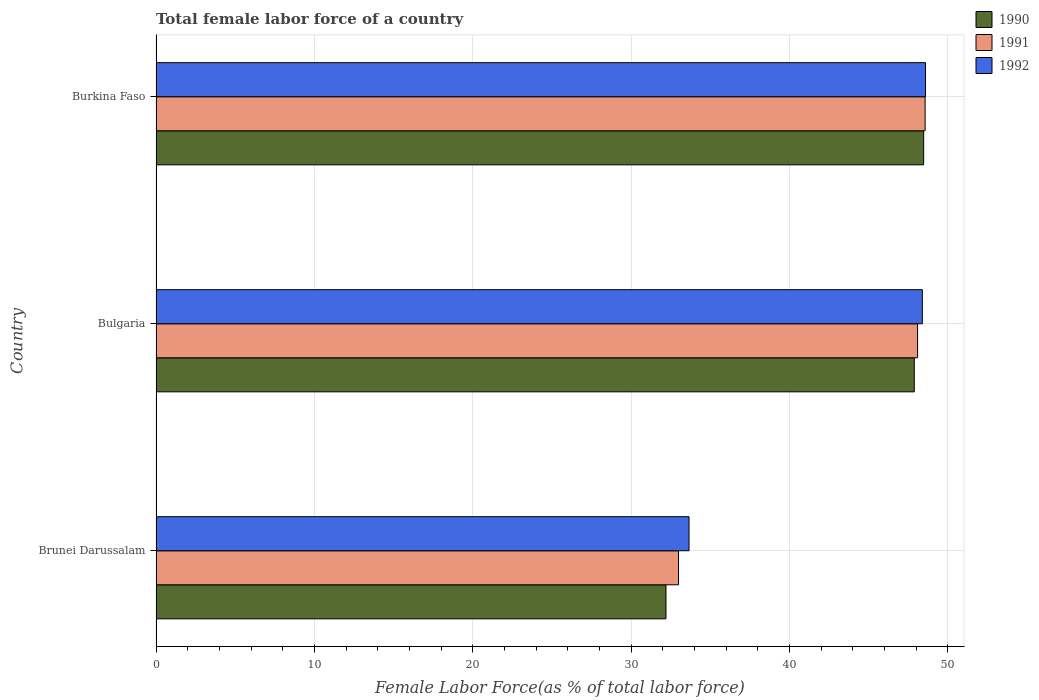How many different coloured bars are there?
Give a very brief answer. 3. How many bars are there on the 2nd tick from the top?
Ensure brevity in your answer.  3. How many bars are there on the 2nd tick from the bottom?
Your response must be concise. 3. What is the label of the 2nd group of bars from the top?
Offer a terse response. Bulgaria. In how many cases, is the number of bars for a given country not equal to the number of legend labels?
Your response must be concise. 0. What is the percentage of female labor force in 1992 in Burkina Faso?
Ensure brevity in your answer.  48.59. Across all countries, what is the maximum percentage of female labor force in 1992?
Your response must be concise. 48.59. Across all countries, what is the minimum percentage of female labor force in 1992?
Offer a terse response. 33.66. In which country was the percentage of female labor force in 1990 maximum?
Provide a short and direct response. Burkina Faso. In which country was the percentage of female labor force in 1990 minimum?
Ensure brevity in your answer.  Brunei Darussalam. What is the total percentage of female labor force in 1992 in the graph?
Offer a very short reply. 130.65. What is the difference between the percentage of female labor force in 1991 in Bulgaria and that in Burkina Faso?
Your answer should be compact. -0.48. What is the difference between the percentage of female labor force in 1992 in Brunei Darussalam and the percentage of female labor force in 1991 in Bulgaria?
Give a very brief answer. -14.43. What is the average percentage of female labor force in 1992 per country?
Offer a very short reply. 43.55. What is the difference between the percentage of female labor force in 1992 and percentage of female labor force in 1991 in Burkina Faso?
Make the answer very short. 0.03. In how many countries, is the percentage of female labor force in 1991 greater than 12 %?
Provide a short and direct response. 3. What is the ratio of the percentage of female labor force in 1990 in Brunei Darussalam to that in Bulgaria?
Make the answer very short. 0.67. Is the percentage of female labor force in 1990 in Bulgaria less than that in Burkina Faso?
Keep it short and to the point. Yes. What is the difference between the highest and the second highest percentage of female labor force in 1990?
Offer a terse response. 0.59. What is the difference between the highest and the lowest percentage of female labor force in 1991?
Your response must be concise. 15.57. In how many countries, is the percentage of female labor force in 1990 greater than the average percentage of female labor force in 1990 taken over all countries?
Offer a terse response. 2. Is the sum of the percentage of female labor force in 1992 in Brunei Darussalam and Bulgaria greater than the maximum percentage of female labor force in 1991 across all countries?
Your answer should be very brief. Yes. What does the 2nd bar from the bottom in Brunei Darussalam represents?
Ensure brevity in your answer.  1991. How many bars are there?
Offer a terse response. 9. Are all the bars in the graph horizontal?
Offer a very short reply. Yes. How many countries are there in the graph?
Make the answer very short. 3. What is the difference between two consecutive major ticks on the X-axis?
Give a very brief answer. 10. Are the values on the major ticks of X-axis written in scientific E-notation?
Make the answer very short. No. Does the graph contain grids?
Ensure brevity in your answer.  Yes. How many legend labels are there?
Make the answer very short. 3. How are the legend labels stacked?
Give a very brief answer. Vertical. What is the title of the graph?
Ensure brevity in your answer.  Total female labor force of a country. What is the label or title of the X-axis?
Provide a succinct answer. Female Labor Force(as % of total labor force). What is the Female Labor Force(as % of total labor force) in 1990 in Brunei Darussalam?
Keep it short and to the point. 32.2. What is the Female Labor Force(as % of total labor force) of 1991 in Brunei Darussalam?
Your response must be concise. 33. What is the Female Labor Force(as % of total labor force) of 1992 in Brunei Darussalam?
Ensure brevity in your answer.  33.66. What is the Female Labor Force(as % of total labor force) in 1990 in Bulgaria?
Your response must be concise. 47.88. What is the Female Labor Force(as % of total labor force) in 1991 in Bulgaria?
Provide a succinct answer. 48.09. What is the Female Labor Force(as % of total labor force) of 1992 in Bulgaria?
Give a very brief answer. 48.39. What is the Female Labor Force(as % of total labor force) of 1990 in Burkina Faso?
Give a very brief answer. 48.48. What is the Female Labor Force(as % of total labor force) of 1991 in Burkina Faso?
Provide a short and direct response. 48.57. What is the Female Labor Force(as % of total labor force) of 1992 in Burkina Faso?
Your answer should be compact. 48.59. Across all countries, what is the maximum Female Labor Force(as % of total labor force) in 1990?
Your answer should be compact. 48.48. Across all countries, what is the maximum Female Labor Force(as % of total labor force) of 1991?
Your answer should be very brief. 48.57. Across all countries, what is the maximum Female Labor Force(as % of total labor force) of 1992?
Your answer should be compact. 48.59. Across all countries, what is the minimum Female Labor Force(as % of total labor force) of 1990?
Provide a short and direct response. 32.2. Across all countries, what is the minimum Female Labor Force(as % of total labor force) of 1991?
Your response must be concise. 33. Across all countries, what is the minimum Female Labor Force(as % of total labor force) of 1992?
Keep it short and to the point. 33.66. What is the total Female Labor Force(as % of total labor force) in 1990 in the graph?
Offer a very short reply. 128.57. What is the total Female Labor Force(as % of total labor force) of 1991 in the graph?
Your response must be concise. 129.66. What is the total Female Labor Force(as % of total labor force) of 1992 in the graph?
Provide a short and direct response. 130.65. What is the difference between the Female Labor Force(as % of total labor force) in 1990 in Brunei Darussalam and that in Bulgaria?
Give a very brief answer. -15.68. What is the difference between the Female Labor Force(as % of total labor force) of 1991 in Brunei Darussalam and that in Bulgaria?
Your response must be concise. -15.1. What is the difference between the Female Labor Force(as % of total labor force) in 1992 in Brunei Darussalam and that in Bulgaria?
Offer a very short reply. -14.73. What is the difference between the Female Labor Force(as % of total labor force) in 1990 in Brunei Darussalam and that in Burkina Faso?
Your response must be concise. -16.27. What is the difference between the Female Labor Force(as % of total labor force) in 1991 in Brunei Darussalam and that in Burkina Faso?
Provide a short and direct response. -15.57. What is the difference between the Female Labor Force(as % of total labor force) in 1992 in Brunei Darussalam and that in Burkina Faso?
Ensure brevity in your answer.  -14.93. What is the difference between the Female Labor Force(as % of total labor force) in 1990 in Bulgaria and that in Burkina Faso?
Make the answer very short. -0.59. What is the difference between the Female Labor Force(as % of total labor force) in 1991 in Bulgaria and that in Burkina Faso?
Your response must be concise. -0.48. What is the difference between the Female Labor Force(as % of total labor force) of 1992 in Bulgaria and that in Burkina Faso?
Give a very brief answer. -0.2. What is the difference between the Female Labor Force(as % of total labor force) of 1990 in Brunei Darussalam and the Female Labor Force(as % of total labor force) of 1991 in Bulgaria?
Ensure brevity in your answer.  -15.89. What is the difference between the Female Labor Force(as % of total labor force) in 1990 in Brunei Darussalam and the Female Labor Force(as % of total labor force) in 1992 in Bulgaria?
Keep it short and to the point. -16.19. What is the difference between the Female Labor Force(as % of total labor force) of 1991 in Brunei Darussalam and the Female Labor Force(as % of total labor force) of 1992 in Bulgaria?
Give a very brief answer. -15.4. What is the difference between the Female Labor Force(as % of total labor force) in 1990 in Brunei Darussalam and the Female Labor Force(as % of total labor force) in 1991 in Burkina Faso?
Provide a short and direct response. -16.36. What is the difference between the Female Labor Force(as % of total labor force) of 1990 in Brunei Darussalam and the Female Labor Force(as % of total labor force) of 1992 in Burkina Faso?
Keep it short and to the point. -16.39. What is the difference between the Female Labor Force(as % of total labor force) of 1991 in Brunei Darussalam and the Female Labor Force(as % of total labor force) of 1992 in Burkina Faso?
Your response must be concise. -15.6. What is the difference between the Female Labor Force(as % of total labor force) of 1990 in Bulgaria and the Female Labor Force(as % of total labor force) of 1991 in Burkina Faso?
Your answer should be compact. -0.68. What is the difference between the Female Labor Force(as % of total labor force) of 1990 in Bulgaria and the Female Labor Force(as % of total labor force) of 1992 in Burkina Faso?
Your response must be concise. -0.71. What is the difference between the Female Labor Force(as % of total labor force) in 1991 in Bulgaria and the Female Labor Force(as % of total labor force) in 1992 in Burkina Faso?
Your response must be concise. -0.5. What is the average Female Labor Force(as % of total labor force) in 1990 per country?
Make the answer very short. 42.86. What is the average Female Labor Force(as % of total labor force) of 1991 per country?
Provide a succinct answer. 43.22. What is the average Female Labor Force(as % of total labor force) of 1992 per country?
Make the answer very short. 43.55. What is the difference between the Female Labor Force(as % of total labor force) of 1990 and Female Labor Force(as % of total labor force) of 1991 in Brunei Darussalam?
Offer a terse response. -0.79. What is the difference between the Female Labor Force(as % of total labor force) in 1990 and Female Labor Force(as % of total labor force) in 1992 in Brunei Darussalam?
Make the answer very short. -1.46. What is the difference between the Female Labor Force(as % of total labor force) in 1991 and Female Labor Force(as % of total labor force) in 1992 in Brunei Darussalam?
Provide a succinct answer. -0.66. What is the difference between the Female Labor Force(as % of total labor force) of 1990 and Female Labor Force(as % of total labor force) of 1991 in Bulgaria?
Provide a succinct answer. -0.21. What is the difference between the Female Labor Force(as % of total labor force) of 1990 and Female Labor Force(as % of total labor force) of 1992 in Bulgaria?
Give a very brief answer. -0.51. What is the difference between the Female Labor Force(as % of total labor force) of 1991 and Female Labor Force(as % of total labor force) of 1992 in Bulgaria?
Your answer should be very brief. -0.3. What is the difference between the Female Labor Force(as % of total labor force) in 1990 and Female Labor Force(as % of total labor force) in 1991 in Burkina Faso?
Offer a terse response. -0.09. What is the difference between the Female Labor Force(as % of total labor force) of 1990 and Female Labor Force(as % of total labor force) of 1992 in Burkina Faso?
Provide a succinct answer. -0.12. What is the difference between the Female Labor Force(as % of total labor force) in 1991 and Female Labor Force(as % of total labor force) in 1992 in Burkina Faso?
Your response must be concise. -0.03. What is the ratio of the Female Labor Force(as % of total labor force) in 1990 in Brunei Darussalam to that in Bulgaria?
Keep it short and to the point. 0.67. What is the ratio of the Female Labor Force(as % of total labor force) of 1991 in Brunei Darussalam to that in Bulgaria?
Your answer should be very brief. 0.69. What is the ratio of the Female Labor Force(as % of total labor force) in 1992 in Brunei Darussalam to that in Bulgaria?
Provide a succinct answer. 0.7. What is the ratio of the Female Labor Force(as % of total labor force) in 1990 in Brunei Darussalam to that in Burkina Faso?
Keep it short and to the point. 0.66. What is the ratio of the Female Labor Force(as % of total labor force) in 1991 in Brunei Darussalam to that in Burkina Faso?
Offer a terse response. 0.68. What is the ratio of the Female Labor Force(as % of total labor force) of 1992 in Brunei Darussalam to that in Burkina Faso?
Offer a very short reply. 0.69. What is the ratio of the Female Labor Force(as % of total labor force) in 1990 in Bulgaria to that in Burkina Faso?
Offer a terse response. 0.99. What is the ratio of the Female Labor Force(as % of total labor force) in 1991 in Bulgaria to that in Burkina Faso?
Provide a short and direct response. 0.99. What is the ratio of the Female Labor Force(as % of total labor force) of 1992 in Bulgaria to that in Burkina Faso?
Provide a short and direct response. 1. What is the difference between the highest and the second highest Female Labor Force(as % of total labor force) of 1990?
Your answer should be compact. 0.59. What is the difference between the highest and the second highest Female Labor Force(as % of total labor force) in 1991?
Ensure brevity in your answer.  0.48. What is the difference between the highest and the second highest Female Labor Force(as % of total labor force) in 1992?
Give a very brief answer. 0.2. What is the difference between the highest and the lowest Female Labor Force(as % of total labor force) in 1990?
Offer a very short reply. 16.27. What is the difference between the highest and the lowest Female Labor Force(as % of total labor force) of 1991?
Your answer should be compact. 15.57. What is the difference between the highest and the lowest Female Labor Force(as % of total labor force) of 1992?
Give a very brief answer. 14.93. 